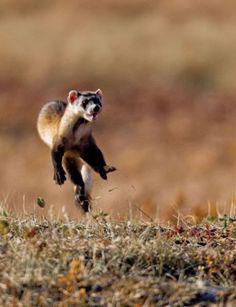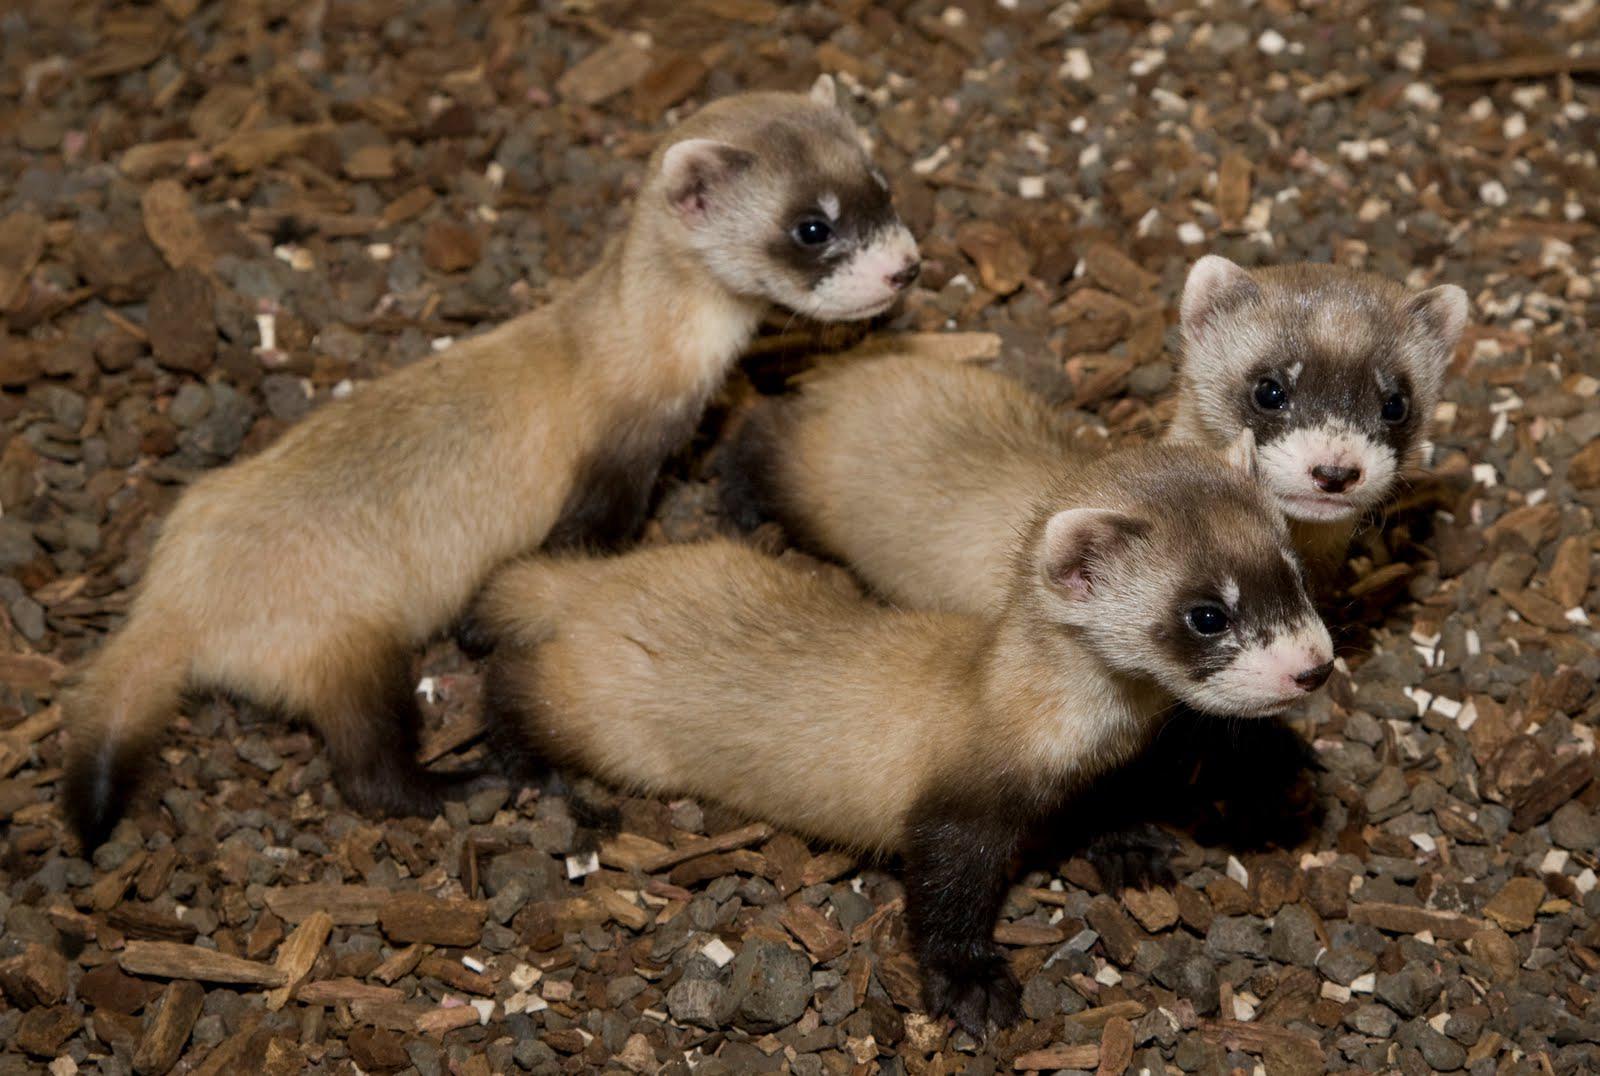The first image is the image on the left, the second image is the image on the right. Assess this claim about the two images: "There are exactly two animals and one is emerging from a hole in the dirt.". Correct or not? Answer yes or no. No. The first image is the image on the left, the second image is the image on the right. Analyze the images presented: Is the assertion "The Muscatel is partly viable as they come out of the dirt hole in the ground." valid? Answer yes or no. No. 